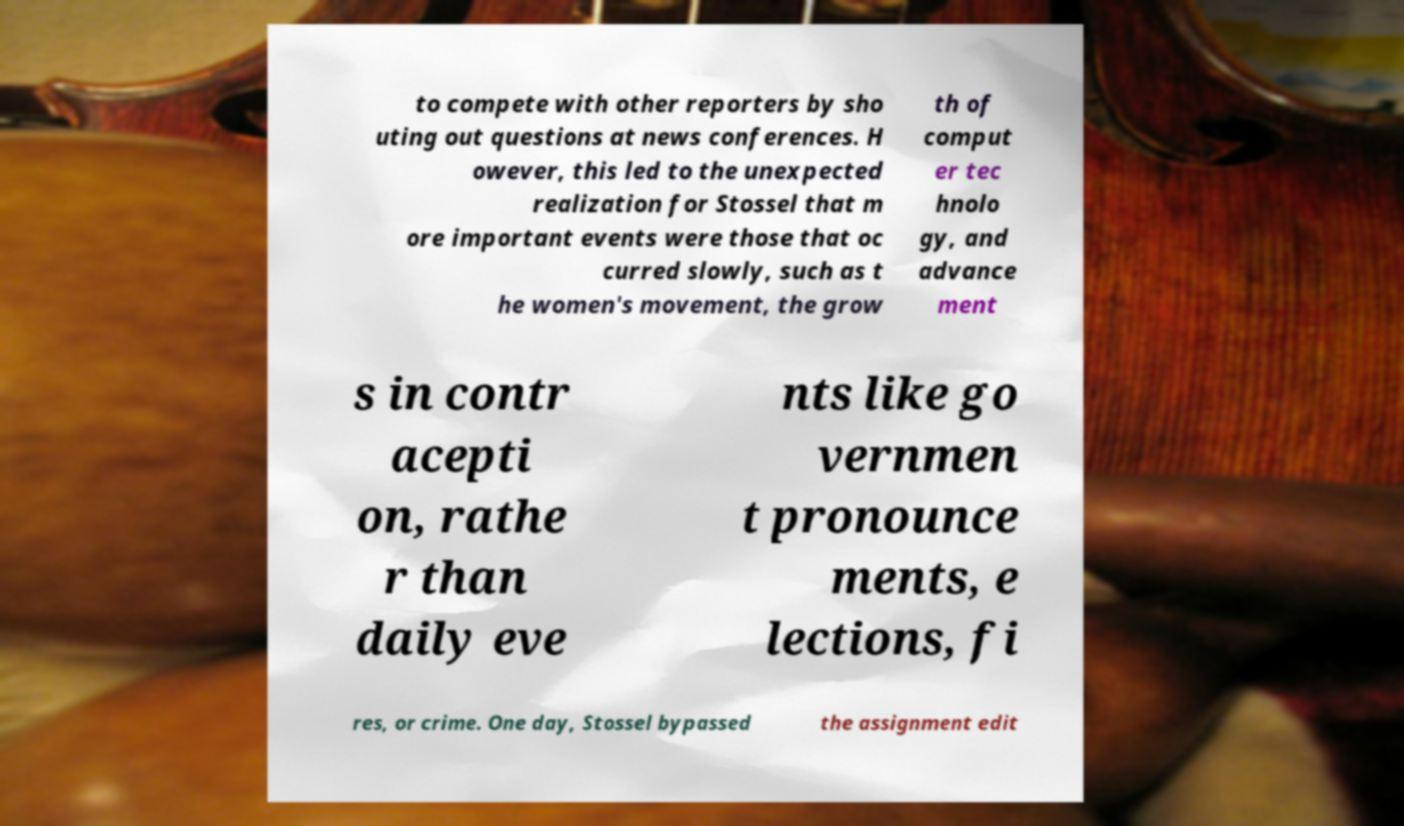Could you assist in decoding the text presented in this image and type it out clearly? to compete with other reporters by sho uting out questions at news conferences. H owever, this led to the unexpected realization for Stossel that m ore important events were those that oc curred slowly, such as t he women's movement, the grow th of comput er tec hnolo gy, and advance ment s in contr acepti on, rathe r than daily eve nts like go vernmen t pronounce ments, e lections, fi res, or crime. One day, Stossel bypassed the assignment edit 